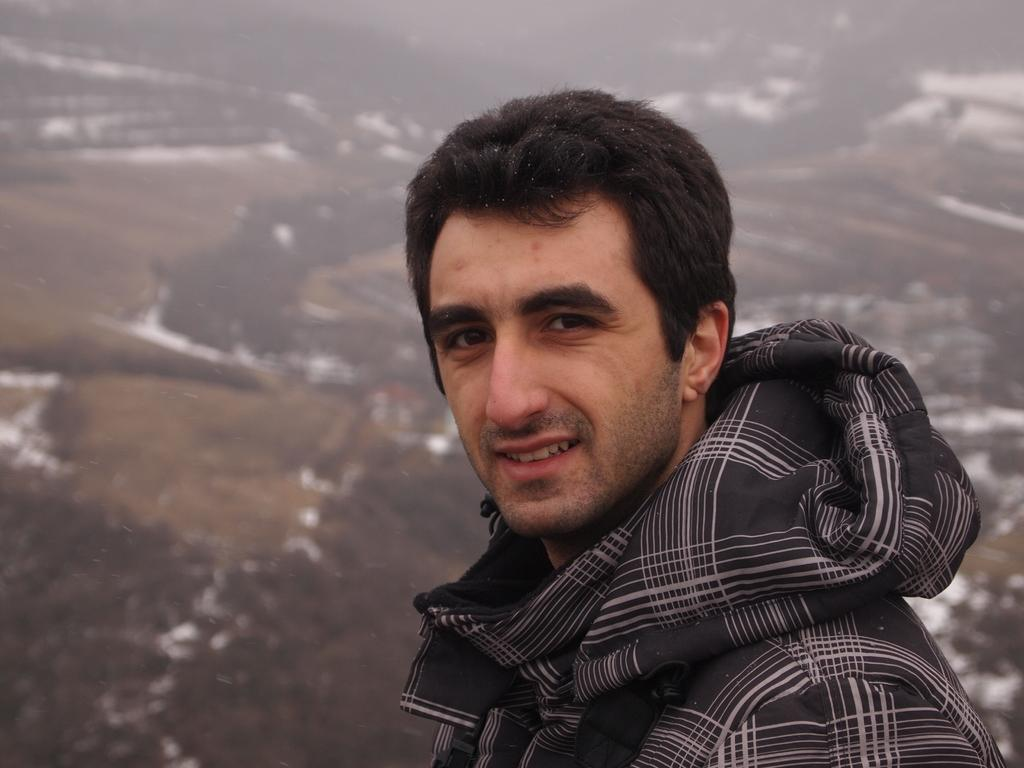Who is present in the image? There is a man in the image. What is the man doing in the image? The man is standing in the image. What is the man wearing in the image? The man is wearing a black hoodie in the image. What is the man's facial expression in the image? The man is smiling in the image. What is the condition of the ground in the image? There is snow on the floor in the image. Can you describe the background of the image? The backdrop is blurred in the image. What type of necklace is the man wearing in the image? The man is not wearing a necklace in the image; he is wearing a black hoodie. What record is the man holding in the image? There is no record present in the image; the man is standing in the snow. 